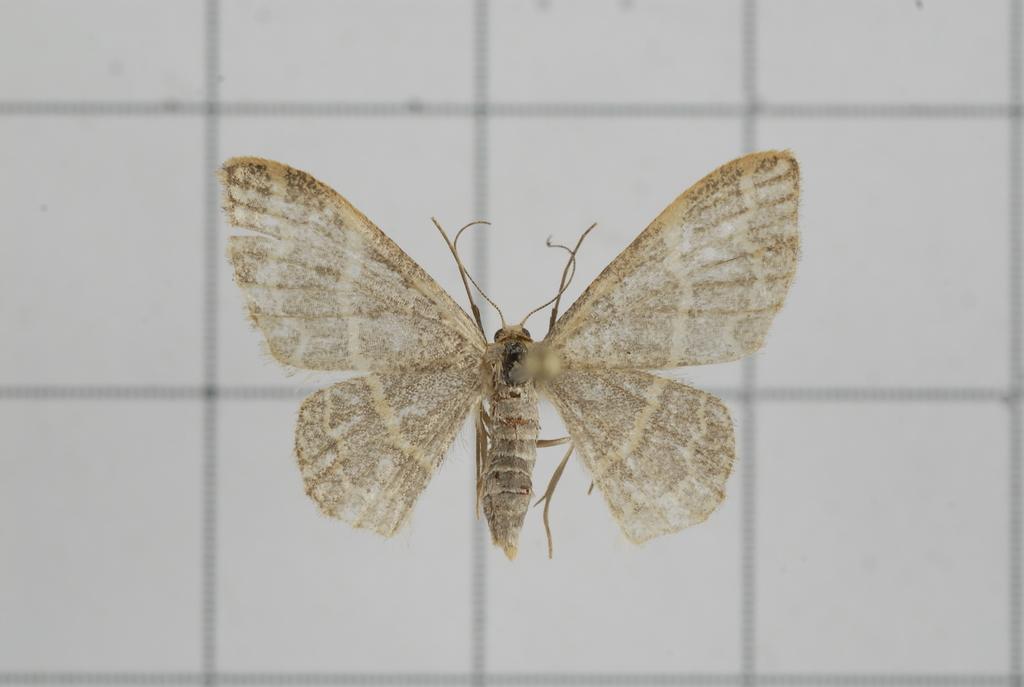Can you describe this image briefly? In the image there is a butterfly on the wall. 